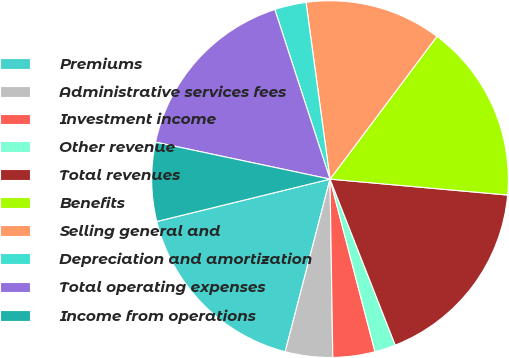<chart> <loc_0><loc_0><loc_500><loc_500><pie_chart><fcel>Premiums<fcel>Administrative services fees<fcel>Investment income<fcel>Other revenue<fcel>Total revenues<fcel>Benefits<fcel>Selling general and<fcel>Depreciation and amortization<fcel>Total operating expenses<fcel>Income from operations<nl><fcel>17.14%<fcel>4.29%<fcel>3.81%<fcel>1.9%<fcel>17.62%<fcel>16.19%<fcel>12.38%<fcel>2.86%<fcel>16.67%<fcel>7.14%<nl></chart> 